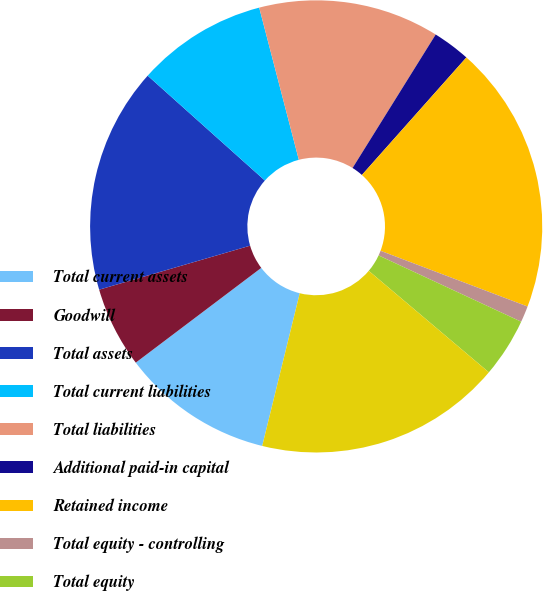<chart> <loc_0><loc_0><loc_500><loc_500><pie_chart><fcel>Total current assets<fcel>Goodwill<fcel>Total assets<fcel>Total current liabilities<fcel>Total liabilities<fcel>Additional paid-in capital<fcel>Retained income<fcel>Total equity - controlling<fcel>Total equity<fcel>Total liabilities and equity<nl><fcel>10.87%<fcel>5.78%<fcel>16.13%<fcel>9.33%<fcel>12.92%<fcel>2.7%<fcel>19.2%<fcel>1.16%<fcel>4.24%<fcel>17.67%<nl></chart> 